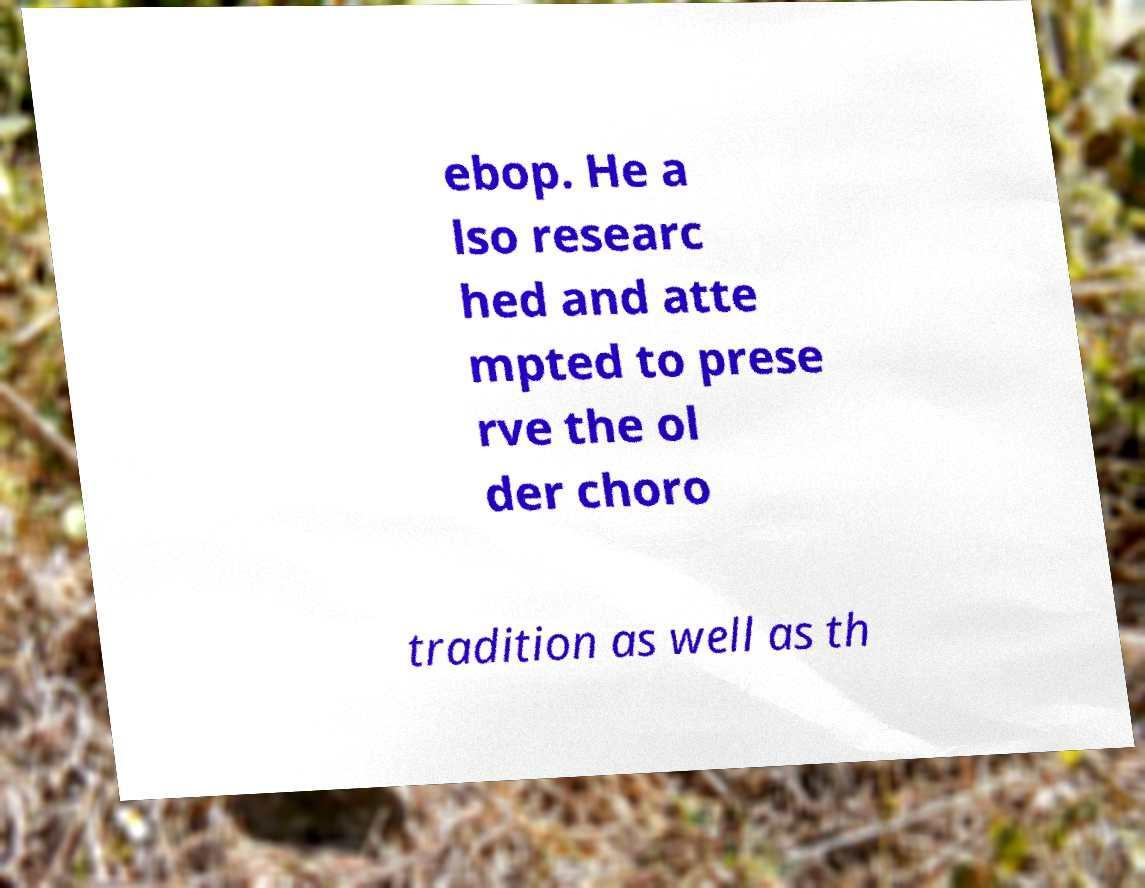What messages or text are displayed in this image? I need them in a readable, typed format. ebop. He a lso researc hed and atte mpted to prese rve the ol der choro tradition as well as th 